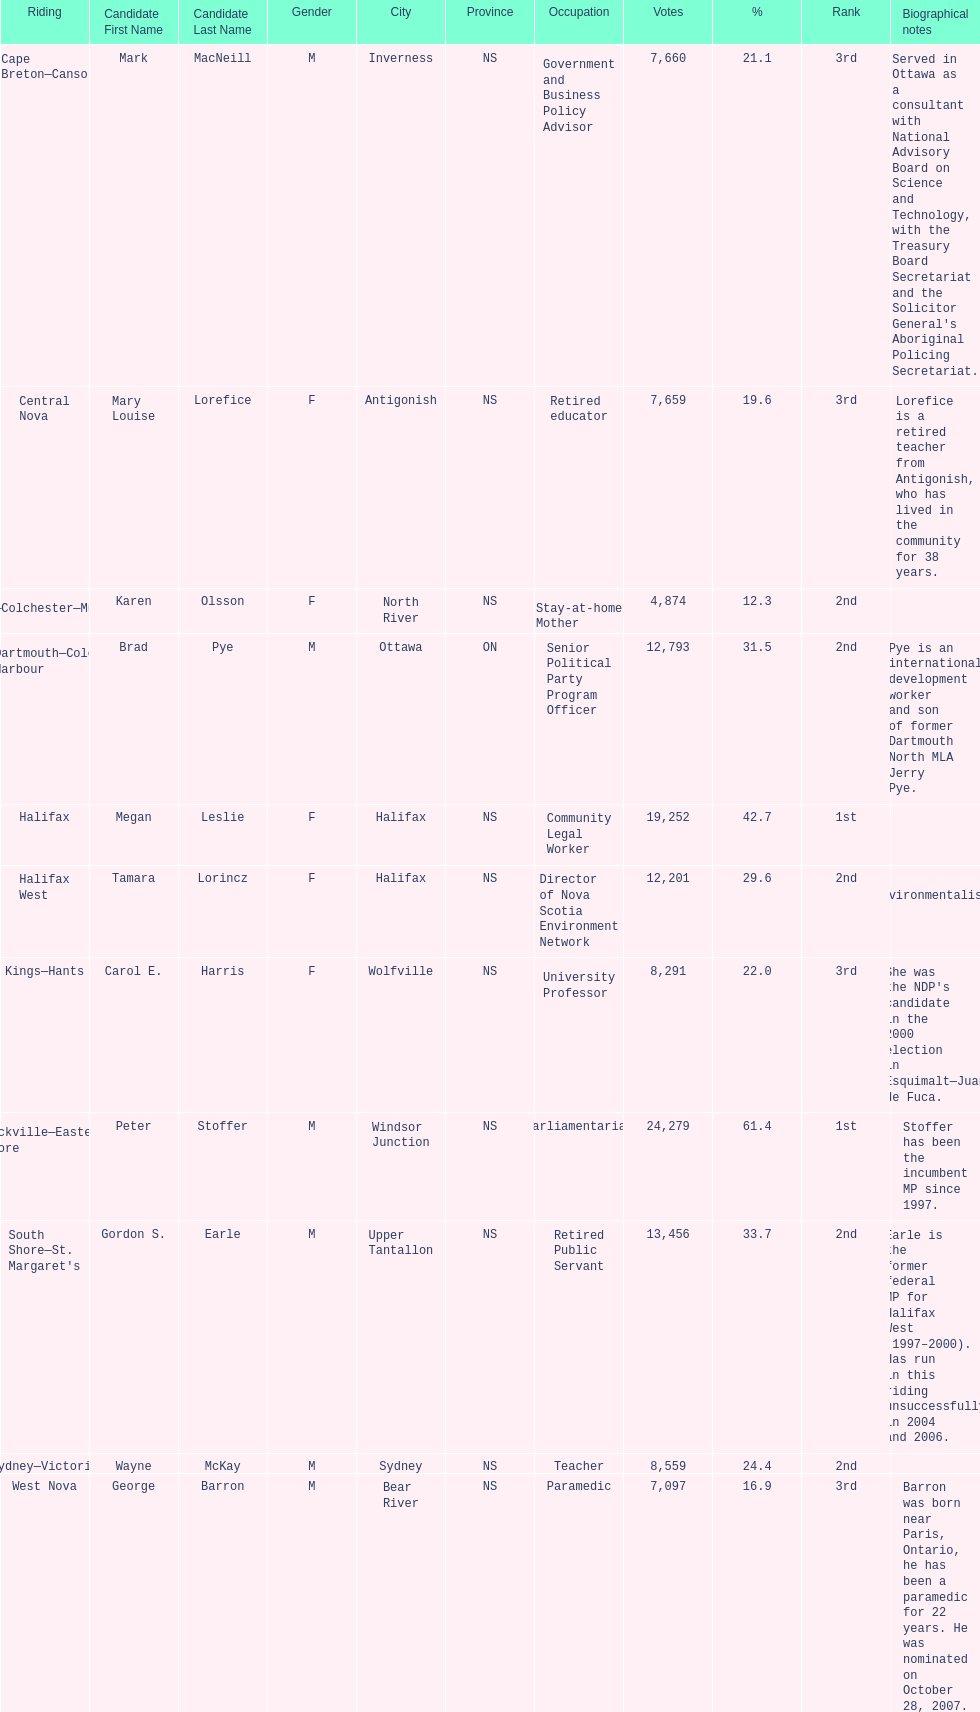What is the number of votes that megan leslie received? 19,252. 